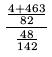Convert formula to latex. <formula><loc_0><loc_0><loc_500><loc_500>\frac { \frac { 4 + 4 6 3 } { 8 2 } } { \frac { 4 8 } { 1 4 2 } }</formula> 